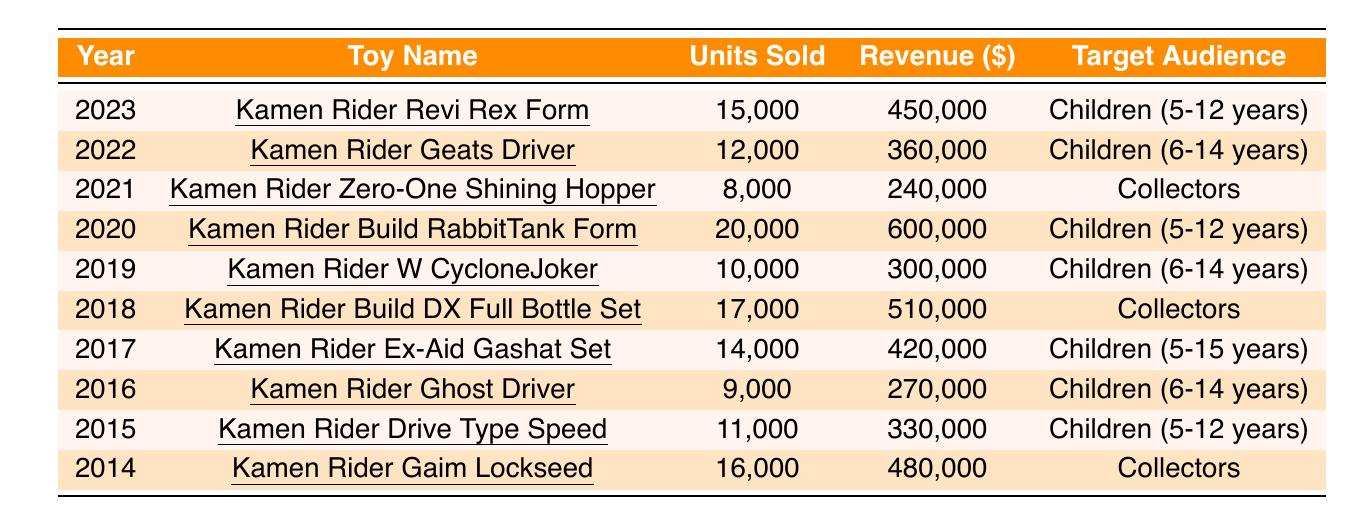What was the revenue from the Kamen Rider Build RabbitTank Form in 2020? According to the table, the revenue for Kamen Rider Build RabbitTank Form in 2020 is listed as 600,000.
Answer: 600,000 Which toy had the highest units sold, and how many were sold? The table shows Kamen Rider Build RabbitTank Form with the highest units sold at 20,000 in 2020.
Answer: Kamen Rider Build RabbitTank Form, 20,000 What is the average number of units sold across all toys from 2014 to 2023? Summing the units sold from 2014 to 2023 gives (16,000 + 11,000 + 9,000 + 14,000 + 17,000 + 10,000 + 20,000 + 8,000 + 12,000 + 15,000) = 132,000. There are 10 data points, so the average is 132,000 / 10 = 13,200.
Answer: 13,200 Is the Kamen Rider Ex-Aid Gashat Set targeted at children? The table indicates that Kamen Rider Ex-Aid Gashat Set targets "Children (5-15 years)", confirming it is targeted at children.
Answer: Yes How much revenue did Kamen Rider Geats Driver generate compared to Kamen Rider Zero-One Shining Hopper? The revenue for Kamen Rider Geats Driver is 360,000 and for Kamen Rider Zero-One Shining Hopper, it is 240,000. The difference is 360,000 - 240,000 = 120,000.
Answer: 120,000 Which toy had a higher target audience age group, Kamen Rider W CycloneJoker or Kamen Rider Geats Driver? Kamen Rider W CycloneJoker targets "Children (6-14 years)" while Kamen Rider Geats Driver also targets "Children (6-14 years)". They have the same target audience age group.
Answer: Same What is the total revenue from all toys sold in the year 2022? The revenue for Kamen Rider Geats Driver in 2022 is 360,000. There are no other toys listed for that year, so the total revenue is also 360,000.
Answer: 360,000 How many more units were sold in 2021 than in 2016? Units sold in 2021 were 8,000 (Kamen Rider Zero-One Shining Hopper) and in 2016 they were 9,000 (Kamen Rider Ghost Driver). The difference is 9,000 - 8,000 = 1,000, meaning 1,000 more units were sold in 2016.
Answer: 1,000 Which toy from the list is the most recent and what was its revenue? The most recent toy listed is Kamen Rider Revi Rex Form from 2023, which had a revenue of 450,000.
Answer: Kamen Rider Revi Rex Form, 450,000 How many toys targeted at collectors were sold between 2014 and 2023? The toys targeting collectors are Kamen Rider Zero-One Shining Hopper (8,000), Kamen Rider Build DX Full Bottle Set (17,000), Kamen Rider Gaim Lockseed (16,000) totaling 8,000 + 17,000 + 16,000 = 41,000 units.
Answer: 41,000 